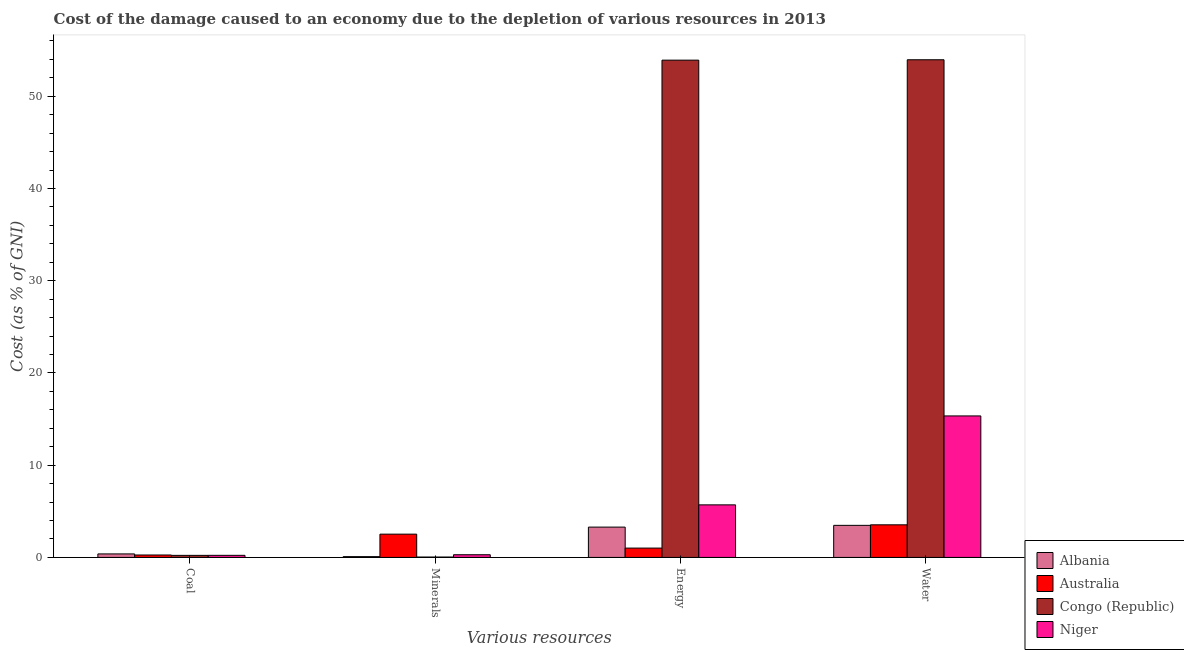How many groups of bars are there?
Offer a very short reply. 4. How many bars are there on the 3rd tick from the left?
Make the answer very short. 4. What is the label of the 2nd group of bars from the left?
Offer a very short reply. Minerals. What is the cost of damage due to depletion of coal in Congo (Republic)?
Offer a very short reply. 0.22. Across all countries, what is the maximum cost of damage due to depletion of minerals?
Offer a terse response. 2.52. Across all countries, what is the minimum cost of damage due to depletion of coal?
Provide a succinct answer. 0.22. In which country was the cost of damage due to depletion of energy maximum?
Offer a terse response. Congo (Republic). In which country was the cost of damage due to depletion of energy minimum?
Your response must be concise. Australia. What is the total cost of damage due to depletion of minerals in the graph?
Offer a very short reply. 2.94. What is the difference between the cost of damage due to depletion of energy in Albania and that in Congo (Republic)?
Ensure brevity in your answer.  -50.63. What is the difference between the cost of damage due to depletion of energy in Australia and the cost of damage due to depletion of minerals in Congo (Republic)?
Give a very brief answer. 0.97. What is the average cost of damage due to depletion of minerals per country?
Offer a very short reply. 0.74. What is the difference between the cost of damage due to depletion of energy and cost of damage due to depletion of coal in Congo (Republic)?
Give a very brief answer. 53.69. In how many countries, is the cost of damage due to depletion of water greater than 20 %?
Give a very brief answer. 1. What is the ratio of the cost of damage due to depletion of energy in Congo (Republic) to that in Albania?
Ensure brevity in your answer.  16.4. What is the difference between the highest and the second highest cost of damage due to depletion of energy?
Your response must be concise. 48.21. What is the difference between the highest and the lowest cost of damage due to depletion of water?
Offer a terse response. 50.48. In how many countries, is the cost of damage due to depletion of energy greater than the average cost of damage due to depletion of energy taken over all countries?
Keep it short and to the point. 1. What does the 2nd bar from the left in Energy represents?
Ensure brevity in your answer.  Australia. What does the 2nd bar from the right in Coal represents?
Give a very brief answer. Congo (Republic). How many bars are there?
Provide a succinct answer. 16. What is the difference between two consecutive major ticks on the Y-axis?
Your answer should be very brief. 10. Where does the legend appear in the graph?
Ensure brevity in your answer.  Bottom right. What is the title of the graph?
Give a very brief answer. Cost of the damage caused to an economy due to the depletion of various resources in 2013 . Does "Armenia" appear as one of the legend labels in the graph?
Offer a very short reply. No. What is the label or title of the X-axis?
Provide a short and direct response. Various resources. What is the label or title of the Y-axis?
Offer a very short reply. Cost (as % of GNI). What is the Cost (as % of GNI) in Albania in Coal?
Ensure brevity in your answer.  0.38. What is the Cost (as % of GNI) in Australia in Coal?
Your answer should be compact. 0.26. What is the Cost (as % of GNI) in Congo (Republic) in Coal?
Ensure brevity in your answer.  0.22. What is the Cost (as % of GNI) in Niger in Coal?
Offer a very short reply. 0.23. What is the Cost (as % of GNI) in Albania in Minerals?
Provide a succinct answer. 0.09. What is the Cost (as % of GNI) of Australia in Minerals?
Provide a short and direct response. 2.52. What is the Cost (as % of GNI) of Congo (Republic) in Minerals?
Your answer should be very brief. 0.04. What is the Cost (as % of GNI) of Niger in Minerals?
Give a very brief answer. 0.29. What is the Cost (as % of GNI) in Albania in Energy?
Provide a succinct answer. 3.29. What is the Cost (as % of GNI) of Australia in Energy?
Make the answer very short. 1.01. What is the Cost (as % of GNI) in Congo (Republic) in Energy?
Offer a very short reply. 53.91. What is the Cost (as % of GNI) of Niger in Energy?
Offer a terse response. 5.7. What is the Cost (as % of GNI) in Albania in Water?
Make the answer very short. 3.48. What is the Cost (as % of GNI) of Australia in Water?
Your answer should be compact. 3.54. What is the Cost (as % of GNI) in Congo (Republic) in Water?
Your answer should be compact. 53.96. What is the Cost (as % of GNI) in Niger in Water?
Your response must be concise. 15.34. Across all Various resources, what is the maximum Cost (as % of GNI) in Albania?
Offer a very short reply. 3.48. Across all Various resources, what is the maximum Cost (as % of GNI) of Australia?
Your answer should be very brief. 3.54. Across all Various resources, what is the maximum Cost (as % of GNI) of Congo (Republic)?
Ensure brevity in your answer.  53.96. Across all Various resources, what is the maximum Cost (as % of GNI) in Niger?
Your response must be concise. 15.34. Across all Various resources, what is the minimum Cost (as % of GNI) in Albania?
Ensure brevity in your answer.  0.09. Across all Various resources, what is the minimum Cost (as % of GNI) of Australia?
Make the answer very short. 0.26. Across all Various resources, what is the minimum Cost (as % of GNI) of Congo (Republic)?
Provide a short and direct response. 0.04. Across all Various resources, what is the minimum Cost (as % of GNI) in Niger?
Your answer should be compact. 0.23. What is the total Cost (as % of GNI) of Albania in the graph?
Provide a short and direct response. 7.23. What is the total Cost (as % of GNI) in Australia in the graph?
Give a very brief answer. 7.33. What is the total Cost (as % of GNI) of Congo (Republic) in the graph?
Keep it short and to the point. 108.14. What is the total Cost (as % of GNI) of Niger in the graph?
Your response must be concise. 21.56. What is the difference between the Cost (as % of GNI) in Albania in Coal and that in Minerals?
Keep it short and to the point. 0.29. What is the difference between the Cost (as % of GNI) of Australia in Coal and that in Minerals?
Your response must be concise. -2.26. What is the difference between the Cost (as % of GNI) of Congo (Republic) in Coal and that in Minerals?
Your answer should be compact. 0.18. What is the difference between the Cost (as % of GNI) in Niger in Coal and that in Minerals?
Ensure brevity in your answer.  -0.06. What is the difference between the Cost (as % of GNI) in Albania in Coal and that in Energy?
Keep it short and to the point. -2.91. What is the difference between the Cost (as % of GNI) of Australia in Coal and that in Energy?
Your answer should be very brief. -0.75. What is the difference between the Cost (as % of GNI) in Congo (Republic) in Coal and that in Energy?
Offer a very short reply. -53.69. What is the difference between the Cost (as % of GNI) of Niger in Coal and that in Energy?
Make the answer very short. -5.47. What is the difference between the Cost (as % of GNI) in Albania in Coal and that in Water?
Offer a very short reply. -3.1. What is the difference between the Cost (as % of GNI) of Australia in Coal and that in Water?
Ensure brevity in your answer.  -3.27. What is the difference between the Cost (as % of GNI) of Congo (Republic) in Coal and that in Water?
Provide a short and direct response. -53.73. What is the difference between the Cost (as % of GNI) in Niger in Coal and that in Water?
Give a very brief answer. -15.11. What is the difference between the Cost (as % of GNI) in Albania in Minerals and that in Energy?
Provide a short and direct response. -3.2. What is the difference between the Cost (as % of GNI) in Australia in Minerals and that in Energy?
Make the answer very short. 1.51. What is the difference between the Cost (as % of GNI) of Congo (Republic) in Minerals and that in Energy?
Your response must be concise. -53.87. What is the difference between the Cost (as % of GNI) in Niger in Minerals and that in Energy?
Make the answer very short. -5.41. What is the difference between the Cost (as % of GNI) of Albania in Minerals and that in Water?
Offer a very short reply. -3.39. What is the difference between the Cost (as % of GNI) in Australia in Minerals and that in Water?
Ensure brevity in your answer.  -1.01. What is the difference between the Cost (as % of GNI) in Congo (Republic) in Minerals and that in Water?
Offer a terse response. -53.91. What is the difference between the Cost (as % of GNI) of Niger in Minerals and that in Water?
Give a very brief answer. -15.05. What is the difference between the Cost (as % of GNI) in Albania in Energy and that in Water?
Ensure brevity in your answer.  -0.19. What is the difference between the Cost (as % of GNI) in Australia in Energy and that in Water?
Give a very brief answer. -2.52. What is the difference between the Cost (as % of GNI) of Congo (Republic) in Energy and that in Water?
Provide a short and direct response. -0.04. What is the difference between the Cost (as % of GNI) in Niger in Energy and that in Water?
Offer a terse response. -9.64. What is the difference between the Cost (as % of GNI) in Albania in Coal and the Cost (as % of GNI) in Australia in Minerals?
Your response must be concise. -2.14. What is the difference between the Cost (as % of GNI) in Albania in Coal and the Cost (as % of GNI) in Congo (Republic) in Minerals?
Give a very brief answer. 0.34. What is the difference between the Cost (as % of GNI) in Albania in Coal and the Cost (as % of GNI) in Niger in Minerals?
Provide a succinct answer. 0.09. What is the difference between the Cost (as % of GNI) in Australia in Coal and the Cost (as % of GNI) in Congo (Republic) in Minerals?
Offer a terse response. 0.22. What is the difference between the Cost (as % of GNI) of Australia in Coal and the Cost (as % of GNI) of Niger in Minerals?
Offer a terse response. -0.03. What is the difference between the Cost (as % of GNI) in Congo (Republic) in Coal and the Cost (as % of GNI) in Niger in Minerals?
Make the answer very short. -0.07. What is the difference between the Cost (as % of GNI) in Albania in Coal and the Cost (as % of GNI) in Australia in Energy?
Your response must be concise. -0.63. What is the difference between the Cost (as % of GNI) of Albania in Coal and the Cost (as % of GNI) of Congo (Republic) in Energy?
Give a very brief answer. -53.53. What is the difference between the Cost (as % of GNI) of Albania in Coal and the Cost (as % of GNI) of Niger in Energy?
Keep it short and to the point. -5.32. What is the difference between the Cost (as % of GNI) in Australia in Coal and the Cost (as % of GNI) in Congo (Republic) in Energy?
Make the answer very short. -53.65. What is the difference between the Cost (as % of GNI) of Australia in Coal and the Cost (as % of GNI) of Niger in Energy?
Make the answer very short. -5.44. What is the difference between the Cost (as % of GNI) in Congo (Republic) in Coal and the Cost (as % of GNI) in Niger in Energy?
Your answer should be compact. -5.48. What is the difference between the Cost (as % of GNI) of Albania in Coal and the Cost (as % of GNI) of Australia in Water?
Your response must be concise. -3.16. What is the difference between the Cost (as % of GNI) of Albania in Coal and the Cost (as % of GNI) of Congo (Republic) in Water?
Your answer should be very brief. -53.58. What is the difference between the Cost (as % of GNI) of Albania in Coal and the Cost (as % of GNI) of Niger in Water?
Provide a short and direct response. -14.96. What is the difference between the Cost (as % of GNI) in Australia in Coal and the Cost (as % of GNI) in Congo (Republic) in Water?
Make the answer very short. -53.69. What is the difference between the Cost (as % of GNI) of Australia in Coal and the Cost (as % of GNI) of Niger in Water?
Make the answer very short. -15.08. What is the difference between the Cost (as % of GNI) of Congo (Republic) in Coal and the Cost (as % of GNI) of Niger in Water?
Give a very brief answer. -15.12. What is the difference between the Cost (as % of GNI) of Albania in Minerals and the Cost (as % of GNI) of Australia in Energy?
Keep it short and to the point. -0.93. What is the difference between the Cost (as % of GNI) in Albania in Minerals and the Cost (as % of GNI) in Congo (Republic) in Energy?
Ensure brevity in your answer.  -53.83. What is the difference between the Cost (as % of GNI) in Albania in Minerals and the Cost (as % of GNI) in Niger in Energy?
Keep it short and to the point. -5.61. What is the difference between the Cost (as % of GNI) in Australia in Minerals and the Cost (as % of GNI) in Congo (Republic) in Energy?
Keep it short and to the point. -51.39. What is the difference between the Cost (as % of GNI) in Australia in Minerals and the Cost (as % of GNI) in Niger in Energy?
Your answer should be very brief. -3.18. What is the difference between the Cost (as % of GNI) of Congo (Republic) in Minerals and the Cost (as % of GNI) of Niger in Energy?
Make the answer very short. -5.66. What is the difference between the Cost (as % of GNI) in Albania in Minerals and the Cost (as % of GNI) in Australia in Water?
Make the answer very short. -3.45. What is the difference between the Cost (as % of GNI) in Albania in Minerals and the Cost (as % of GNI) in Congo (Republic) in Water?
Your response must be concise. -53.87. What is the difference between the Cost (as % of GNI) in Albania in Minerals and the Cost (as % of GNI) in Niger in Water?
Keep it short and to the point. -15.26. What is the difference between the Cost (as % of GNI) in Australia in Minerals and the Cost (as % of GNI) in Congo (Republic) in Water?
Provide a succinct answer. -51.43. What is the difference between the Cost (as % of GNI) in Australia in Minerals and the Cost (as % of GNI) in Niger in Water?
Ensure brevity in your answer.  -12.82. What is the difference between the Cost (as % of GNI) in Congo (Republic) in Minerals and the Cost (as % of GNI) in Niger in Water?
Give a very brief answer. -15.3. What is the difference between the Cost (as % of GNI) in Albania in Energy and the Cost (as % of GNI) in Australia in Water?
Your answer should be very brief. -0.25. What is the difference between the Cost (as % of GNI) in Albania in Energy and the Cost (as % of GNI) in Congo (Republic) in Water?
Provide a succinct answer. -50.67. What is the difference between the Cost (as % of GNI) in Albania in Energy and the Cost (as % of GNI) in Niger in Water?
Keep it short and to the point. -12.05. What is the difference between the Cost (as % of GNI) of Australia in Energy and the Cost (as % of GNI) of Congo (Republic) in Water?
Offer a very short reply. -52.94. What is the difference between the Cost (as % of GNI) of Australia in Energy and the Cost (as % of GNI) of Niger in Water?
Provide a short and direct response. -14.33. What is the difference between the Cost (as % of GNI) of Congo (Republic) in Energy and the Cost (as % of GNI) of Niger in Water?
Provide a succinct answer. 38.57. What is the average Cost (as % of GNI) in Albania per Various resources?
Provide a short and direct response. 1.81. What is the average Cost (as % of GNI) in Australia per Various resources?
Provide a short and direct response. 1.83. What is the average Cost (as % of GNI) of Congo (Republic) per Various resources?
Offer a terse response. 27.03. What is the average Cost (as % of GNI) in Niger per Various resources?
Your response must be concise. 5.39. What is the difference between the Cost (as % of GNI) of Albania and Cost (as % of GNI) of Australia in Coal?
Provide a succinct answer. 0.12. What is the difference between the Cost (as % of GNI) in Albania and Cost (as % of GNI) in Congo (Republic) in Coal?
Offer a very short reply. 0.16. What is the difference between the Cost (as % of GNI) of Albania and Cost (as % of GNI) of Niger in Coal?
Your answer should be compact. 0.15. What is the difference between the Cost (as % of GNI) of Australia and Cost (as % of GNI) of Congo (Republic) in Coal?
Ensure brevity in your answer.  0.04. What is the difference between the Cost (as % of GNI) in Australia and Cost (as % of GNI) in Niger in Coal?
Give a very brief answer. 0.04. What is the difference between the Cost (as % of GNI) of Congo (Republic) and Cost (as % of GNI) of Niger in Coal?
Ensure brevity in your answer.  -0. What is the difference between the Cost (as % of GNI) of Albania and Cost (as % of GNI) of Australia in Minerals?
Your response must be concise. -2.44. What is the difference between the Cost (as % of GNI) of Albania and Cost (as % of GNI) of Congo (Republic) in Minerals?
Your answer should be very brief. 0.04. What is the difference between the Cost (as % of GNI) of Albania and Cost (as % of GNI) of Niger in Minerals?
Ensure brevity in your answer.  -0.21. What is the difference between the Cost (as % of GNI) in Australia and Cost (as % of GNI) in Congo (Republic) in Minerals?
Offer a very short reply. 2.48. What is the difference between the Cost (as % of GNI) of Australia and Cost (as % of GNI) of Niger in Minerals?
Offer a terse response. 2.23. What is the difference between the Cost (as % of GNI) in Congo (Republic) and Cost (as % of GNI) in Niger in Minerals?
Offer a very short reply. -0.25. What is the difference between the Cost (as % of GNI) in Albania and Cost (as % of GNI) in Australia in Energy?
Your response must be concise. 2.28. What is the difference between the Cost (as % of GNI) of Albania and Cost (as % of GNI) of Congo (Republic) in Energy?
Offer a very short reply. -50.63. What is the difference between the Cost (as % of GNI) of Albania and Cost (as % of GNI) of Niger in Energy?
Provide a short and direct response. -2.41. What is the difference between the Cost (as % of GNI) in Australia and Cost (as % of GNI) in Congo (Republic) in Energy?
Offer a very short reply. -52.9. What is the difference between the Cost (as % of GNI) in Australia and Cost (as % of GNI) in Niger in Energy?
Ensure brevity in your answer.  -4.69. What is the difference between the Cost (as % of GNI) in Congo (Republic) and Cost (as % of GNI) in Niger in Energy?
Ensure brevity in your answer.  48.21. What is the difference between the Cost (as % of GNI) of Albania and Cost (as % of GNI) of Australia in Water?
Your answer should be compact. -0.06. What is the difference between the Cost (as % of GNI) in Albania and Cost (as % of GNI) in Congo (Republic) in Water?
Give a very brief answer. -50.48. What is the difference between the Cost (as % of GNI) in Albania and Cost (as % of GNI) in Niger in Water?
Make the answer very short. -11.86. What is the difference between the Cost (as % of GNI) of Australia and Cost (as % of GNI) of Congo (Republic) in Water?
Your response must be concise. -50.42. What is the difference between the Cost (as % of GNI) in Australia and Cost (as % of GNI) in Niger in Water?
Provide a short and direct response. -11.81. What is the difference between the Cost (as % of GNI) of Congo (Republic) and Cost (as % of GNI) of Niger in Water?
Offer a terse response. 38.61. What is the ratio of the Cost (as % of GNI) of Albania in Coal to that in Minerals?
Provide a short and direct response. 4.43. What is the ratio of the Cost (as % of GNI) of Australia in Coal to that in Minerals?
Your answer should be compact. 0.1. What is the ratio of the Cost (as % of GNI) in Congo (Republic) in Coal to that in Minerals?
Offer a very short reply. 5.29. What is the ratio of the Cost (as % of GNI) in Niger in Coal to that in Minerals?
Your answer should be very brief. 0.78. What is the ratio of the Cost (as % of GNI) of Albania in Coal to that in Energy?
Offer a very short reply. 0.12. What is the ratio of the Cost (as % of GNI) in Australia in Coal to that in Energy?
Offer a very short reply. 0.26. What is the ratio of the Cost (as % of GNI) of Congo (Republic) in Coal to that in Energy?
Your answer should be very brief. 0. What is the ratio of the Cost (as % of GNI) in Niger in Coal to that in Energy?
Ensure brevity in your answer.  0.04. What is the ratio of the Cost (as % of GNI) in Albania in Coal to that in Water?
Give a very brief answer. 0.11. What is the ratio of the Cost (as % of GNI) in Australia in Coal to that in Water?
Your response must be concise. 0.07. What is the ratio of the Cost (as % of GNI) in Congo (Republic) in Coal to that in Water?
Ensure brevity in your answer.  0. What is the ratio of the Cost (as % of GNI) of Niger in Coal to that in Water?
Make the answer very short. 0.01. What is the ratio of the Cost (as % of GNI) in Albania in Minerals to that in Energy?
Your answer should be very brief. 0.03. What is the ratio of the Cost (as % of GNI) in Australia in Minerals to that in Energy?
Your response must be concise. 2.49. What is the ratio of the Cost (as % of GNI) of Congo (Republic) in Minerals to that in Energy?
Your answer should be compact. 0. What is the ratio of the Cost (as % of GNI) in Niger in Minerals to that in Energy?
Keep it short and to the point. 0.05. What is the ratio of the Cost (as % of GNI) of Albania in Minerals to that in Water?
Make the answer very short. 0.02. What is the ratio of the Cost (as % of GNI) of Australia in Minerals to that in Water?
Your answer should be compact. 0.71. What is the ratio of the Cost (as % of GNI) in Congo (Republic) in Minerals to that in Water?
Your answer should be compact. 0. What is the ratio of the Cost (as % of GNI) in Niger in Minerals to that in Water?
Offer a terse response. 0.02. What is the ratio of the Cost (as % of GNI) of Albania in Energy to that in Water?
Offer a very short reply. 0.95. What is the ratio of the Cost (as % of GNI) of Australia in Energy to that in Water?
Your answer should be very brief. 0.29. What is the ratio of the Cost (as % of GNI) in Niger in Energy to that in Water?
Offer a terse response. 0.37. What is the difference between the highest and the second highest Cost (as % of GNI) of Albania?
Offer a very short reply. 0.19. What is the difference between the highest and the second highest Cost (as % of GNI) of Australia?
Make the answer very short. 1.01. What is the difference between the highest and the second highest Cost (as % of GNI) in Congo (Republic)?
Provide a short and direct response. 0.04. What is the difference between the highest and the second highest Cost (as % of GNI) of Niger?
Your answer should be compact. 9.64. What is the difference between the highest and the lowest Cost (as % of GNI) of Albania?
Make the answer very short. 3.39. What is the difference between the highest and the lowest Cost (as % of GNI) in Australia?
Your answer should be compact. 3.27. What is the difference between the highest and the lowest Cost (as % of GNI) of Congo (Republic)?
Offer a very short reply. 53.91. What is the difference between the highest and the lowest Cost (as % of GNI) of Niger?
Offer a terse response. 15.11. 